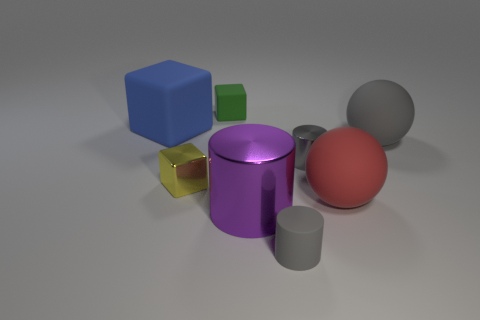What material is the small thing to the left of the matte cube that is behind the large cube?
Provide a short and direct response. Metal. Is the number of gray cylinders that are right of the big cube greater than the number of gray rubber balls?
Keep it short and to the point. Yes. Is there a small yellow object?
Provide a succinct answer. Yes. What is the color of the small rubber thing behind the big blue rubber block?
Your answer should be very brief. Green. There is a gray thing that is the same size as the rubber cylinder; what material is it?
Make the answer very short. Metal. What number of other things are there of the same material as the yellow object
Provide a succinct answer. 2. There is a cylinder that is both behind the small gray matte object and on the left side of the small metallic cylinder; what is its color?
Your response must be concise. Purple. What number of objects are either objects that are behind the big blue rubber thing or large matte balls?
Your answer should be compact. 3. What number of other things are there of the same color as the tiny matte cylinder?
Give a very brief answer. 2. Are there the same number of gray objects to the left of the large purple metal object and big brown metal blocks?
Your answer should be compact. Yes. 